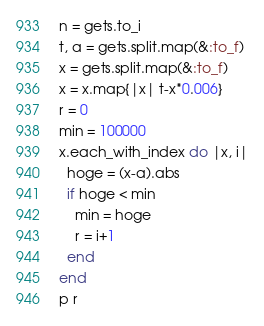Convert code to text. <code><loc_0><loc_0><loc_500><loc_500><_Ruby_>n = gets.to_i
t, a = gets.split.map(&:to_f)
x = gets.split.map(&:to_f)
x = x.map{|x| t-x*0.006}
r = 0
min = 100000
x.each_with_index do |x, i|
  hoge = (x-a).abs
  if hoge < min
    min = hoge
    r = i+1
  end
end
p r</code> 